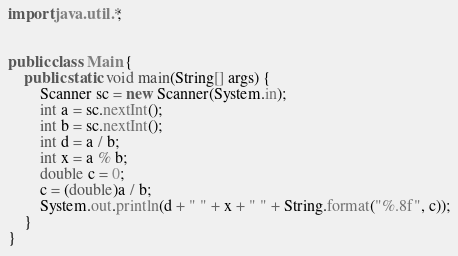<code> <loc_0><loc_0><loc_500><loc_500><_Java_>import java.util.*;


public class Main {
    public static void main(String[] args) {
		Scanner sc = new Scanner(System.in);
		int a = sc.nextInt();
		int b = sc.nextInt();
		int d = a / b;
		int x = a % b;
		double c = 0; 
		c = (double)a / b;
		System.out.println(d + " " + x + " " + String.format("%.8f", c));
    }
}
</code> 